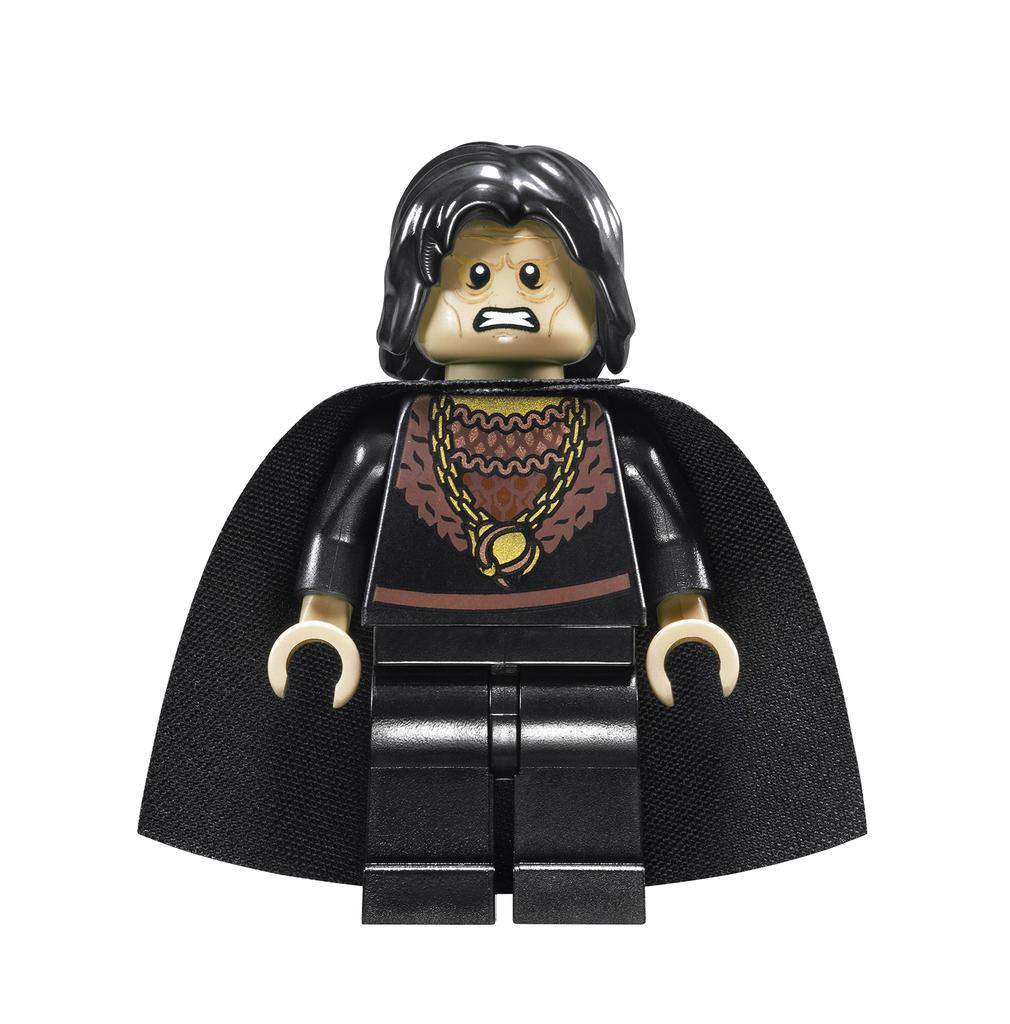What is the main object in the image? There is a toy in the image. What color is the toy's clothing? The toy has black clothing. What color is the background of the image? The background of the image is white. Can you tell me how many boats are docked at the harbor in the image? There is no harbor or boats present in the image; it features a toy with black clothing against a white background. 